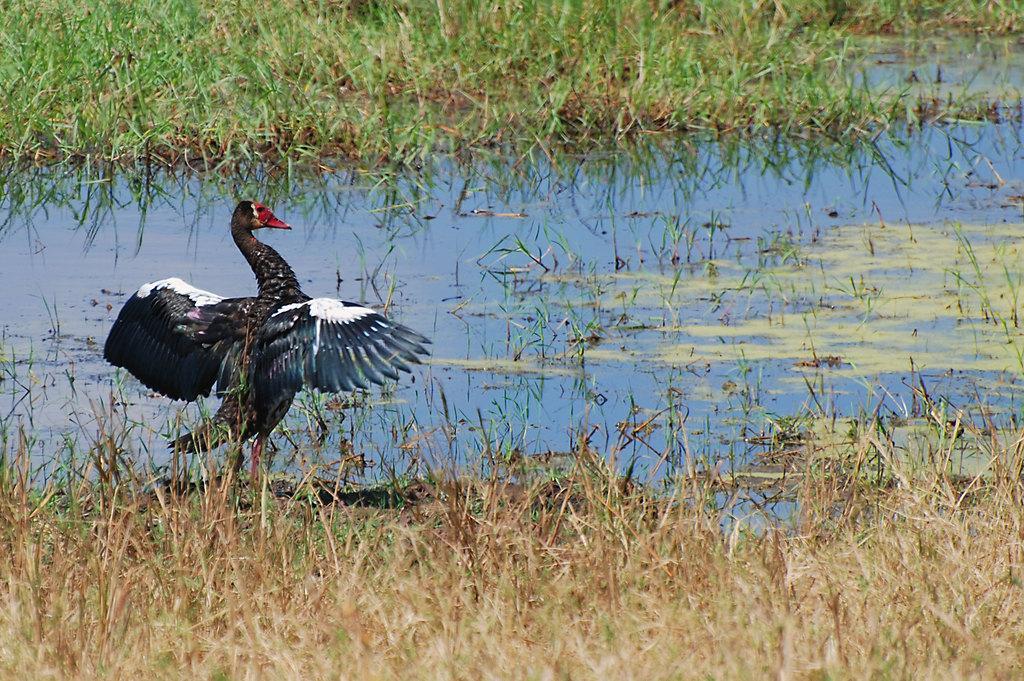Can you describe this image briefly? In this picture we can see grass at the bottom, there is water in the middle, on the left side we can see a cormorant. 